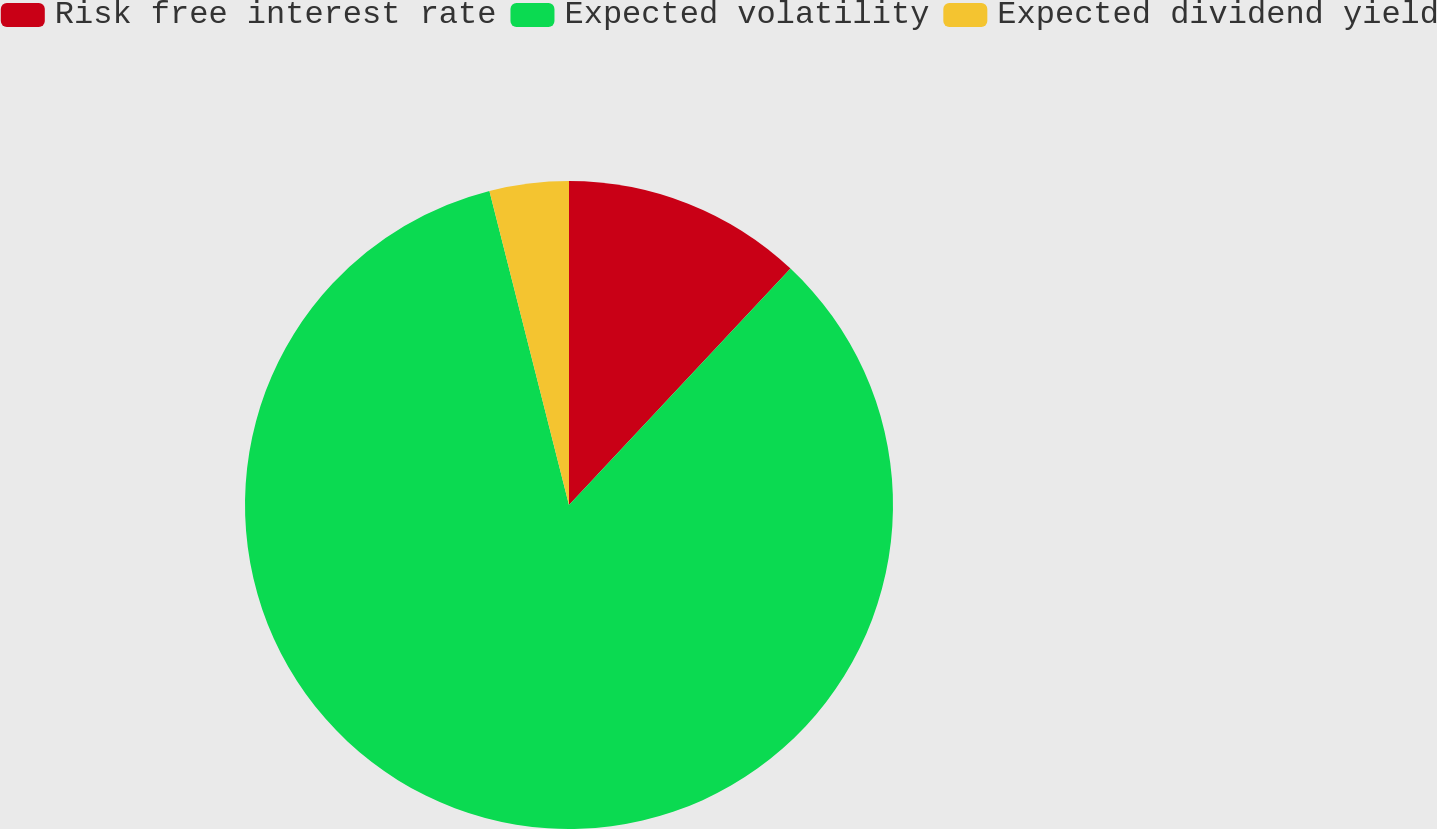Convert chart to OTSL. <chart><loc_0><loc_0><loc_500><loc_500><pie_chart><fcel>Risk free interest rate<fcel>Expected volatility<fcel>Expected dividend yield<nl><fcel>11.98%<fcel>84.07%<fcel>3.95%<nl></chart> 